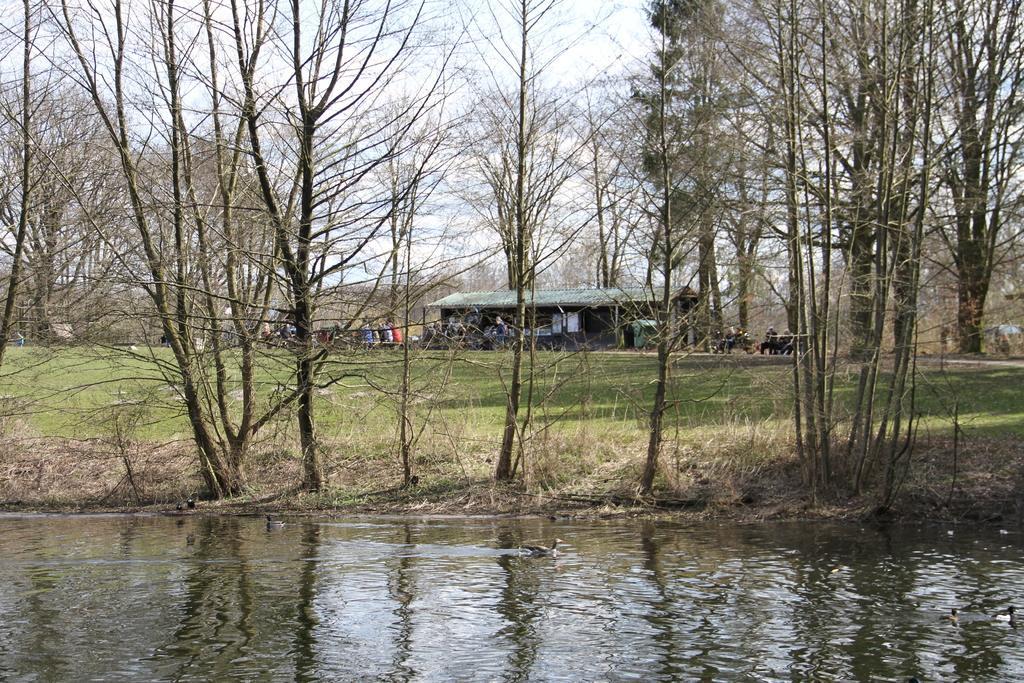In one or two sentences, can you explain what this image depicts? In this picture we can see birds, water, trees and grass. In the background of the image there are people and we can see she and sky. 